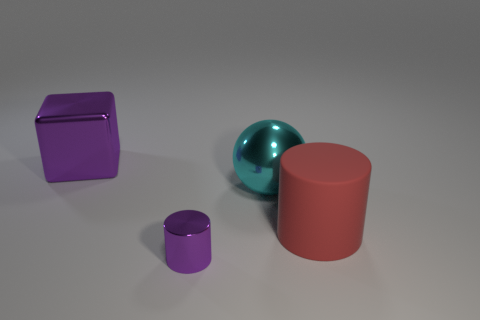Add 2 gray matte objects. How many objects exist? 6 Subtract all red cylinders. How many cylinders are left? 1 Subtract 1 cubes. How many cubes are left? 0 Subtract all brown cubes. Subtract all green spheres. How many cubes are left? 1 Subtract all gray cylinders. How many brown spheres are left? 0 Subtract all large green metallic balls. Subtract all cylinders. How many objects are left? 2 Add 2 purple metal cylinders. How many purple metal cylinders are left? 3 Add 3 small purple metal objects. How many small purple metal objects exist? 4 Subtract 1 red cylinders. How many objects are left? 3 Subtract all balls. How many objects are left? 3 